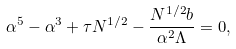Convert formula to latex. <formula><loc_0><loc_0><loc_500><loc_500>\alpha ^ { 5 } - \alpha ^ { 3 } + \tau N ^ { 1 / 2 } - \frac { N ^ { 1 / 2 } b } { \alpha ^ { 2 } \Lambda } = 0 ,</formula> 